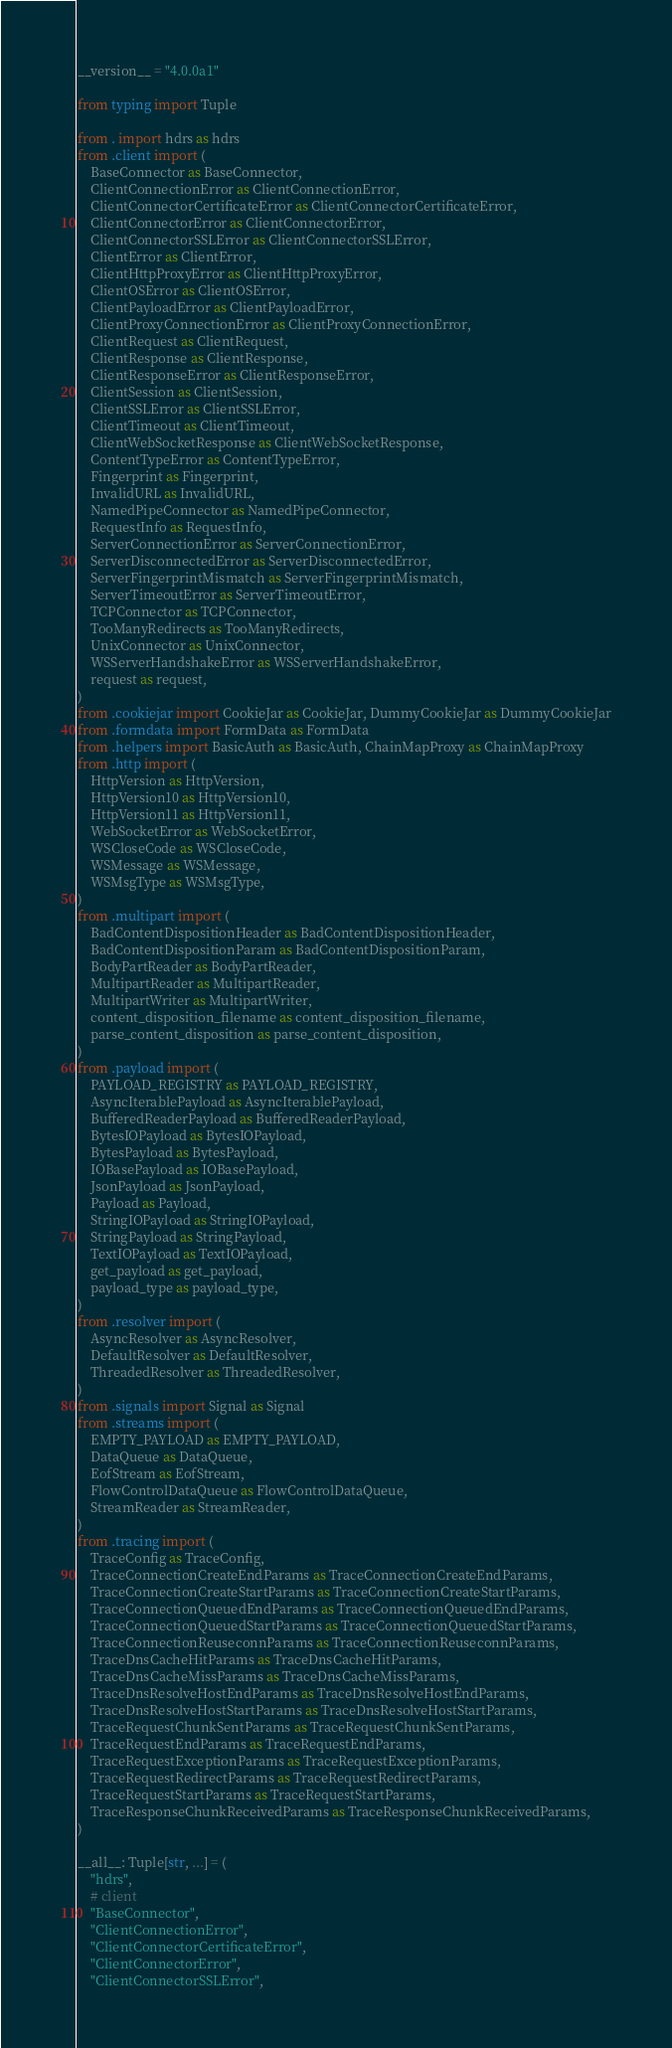<code> <loc_0><loc_0><loc_500><loc_500><_Python_>__version__ = "4.0.0a1"

from typing import Tuple

from . import hdrs as hdrs
from .client import (
    BaseConnector as BaseConnector,
    ClientConnectionError as ClientConnectionError,
    ClientConnectorCertificateError as ClientConnectorCertificateError,
    ClientConnectorError as ClientConnectorError,
    ClientConnectorSSLError as ClientConnectorSSLError,
    ClientError as ClientError,
    ClientHttpProxyError as ClientHttpProxyError,
    ClientOSError as ClientOSError,
    ClientPayloadError as ClientPayloadError,
    ClientProxyConnectionError as ClientProxyConnectionError,
    ClientRequest as ClientRequest,
    ClientResponse as ClientResponse,
    ClientResponseError as ClientResponseError,
    ClientSession as ClientSession,
    ClientSSLError as ClientSSLError,
    ClientTimeout as ClientTimeout,
    ClientWebSocketResponse as ClientWebSocketResponse,
    ContentTypeError as ContentTypeError,
    Fingerprint as Fingerprint,
    InvalidURL as InvalidURL,
    NamedPipeConnector as NamedPipeConnector,
    RequestInfo as RequestInfo,
    ServerConnectionError as ServerConnectionError,
    ServerDisconnectedError as ServerDisconnectedError,
    ServerFingerprintMismatch as ServerFingerprintMismatch,
    ServerTimeoutError as ServerTimeoutError,
    TCPConnector as TCPConnector,
    TooManyRedirects as TooManyRedirects,
    UnixConnector as UnixConnector,
    WSServerHandshakeError as WSServerHandshakeError,
    request as request,
)
from .cookiejar import CookieJar as CookieJar, DummyCookieJar as DummyCookieJar
from .formdata import FormData as FormData
from .helpers import BasicAuth as BasicAuth, ChainMapProxy as ChainMapProxy
from .http import (
    HttpVersion as HttpVersion,
    HttpVersion10 as HttpVersion10,
    HttpVersion11 as HttpVersion11,
    WebSocketError as WebSocketError,
    WSCloseCode as WSCloseCode,
    WSMessage as WSMessage,
    WSMsgType as WSMsgType,
)
from .multipart import (
    BadContentDispositionHeader as BadContentDispositionHeader,
    BadContentDispositionParam as BadContentDispositionParam,
    BodyPartReader as BodyPartReader,
    MultipartReader as MultipartReader,
    MultipartWriter as MultipartWriter,
    content_disposition_filename as content_disposition_filename,
    parse_content_disposition as parse_content_disposition,
)
from .payload import (
    PAYLOAD_REGISTRY as PAYLOAD_REGISTRY,
    AsyncIterablePayload as AsyncIterablePayload,
    BufferedReaderPayload as BufferedReaderPayload,
    BytesIOPayload as BytesIOPayload,
    BytesPayload as BytesPayload,
    IOBasePayload as IOBasePayload,
    JsonPayload as JsonPayload,
    Payload as Payload,
    StringIOPayload as StringIOPayload,
    StringPayload as StringPayload,
    TextIOPayload as TextIOPayload,
    get_payload as get_payload,
    payload_type as payload_type,
)
from .resolver import (
    AsyncResolver as AsyncResolver,
    DefaultResolver as DefaultResolver,
    ThreadedResolver as ThreadedResolver,
)
from .signals import Signal as Signal
from .streams import (
    EMPTY_PAYLOAD as EMPTY_PAYLOAD,
    DataQueue as DataQueue,
    EofStream as EofStream,
    FlowControlDataQueue as FlowControlDataQueue,
    StreamReader as StreamReader,
)
from .tracing import (
    TraceConfig as TraceConfig,
    TraceConnectionCreateEndParams as TraceConnectionCreateEndParams,
    TraceConnectionCreateStartParams as TraceConnectionCreateStartParams,
    TraceConnectionQueuedEndParams as TraceConnectionQueuedEndParams,
    TraceConnectionQueuedStartParams as TraceConnectionQueuedStartParams,
    TraceConnectionReuseconnParams as TraceConnectionReuseconnParams,
    TraceDnsCacheHitParams as TraceDnsCacheHitParams,
    TraceDnsCacheMissParams as TraceDnsCacheMissParams,
    TraceDnsResolveHostEndParams as TraceDnsResolveHostEndParams,
    TraceDnsResolveHostStartParams as TraceDnsResolveHostStartParams,
    TraceRequestChunkSentParams as TraceRequestChunkSentParams,
    TraceRequestEndParams as TraceRequestEndParams,
    TraceRequestExceptionParams as TraceRequestExceptionParams,
    TraceRequestRedirectParams as TraceRequestRedirectParams,
    TraceRequestStartParams as TraceRequestStartParams,
    TraceResponseChunkReceivedParams as TraceResponseChunkReceivedParams,
)

__all__: Tuple[str, ...] = (
    "hdrs",
    # client
    "BaseConnector",
    "ClientConnectionError",
    "ClientConnectorCertificateError",
    "ClientConnectorError",
    "ClientConnectorSSLError",</code> 